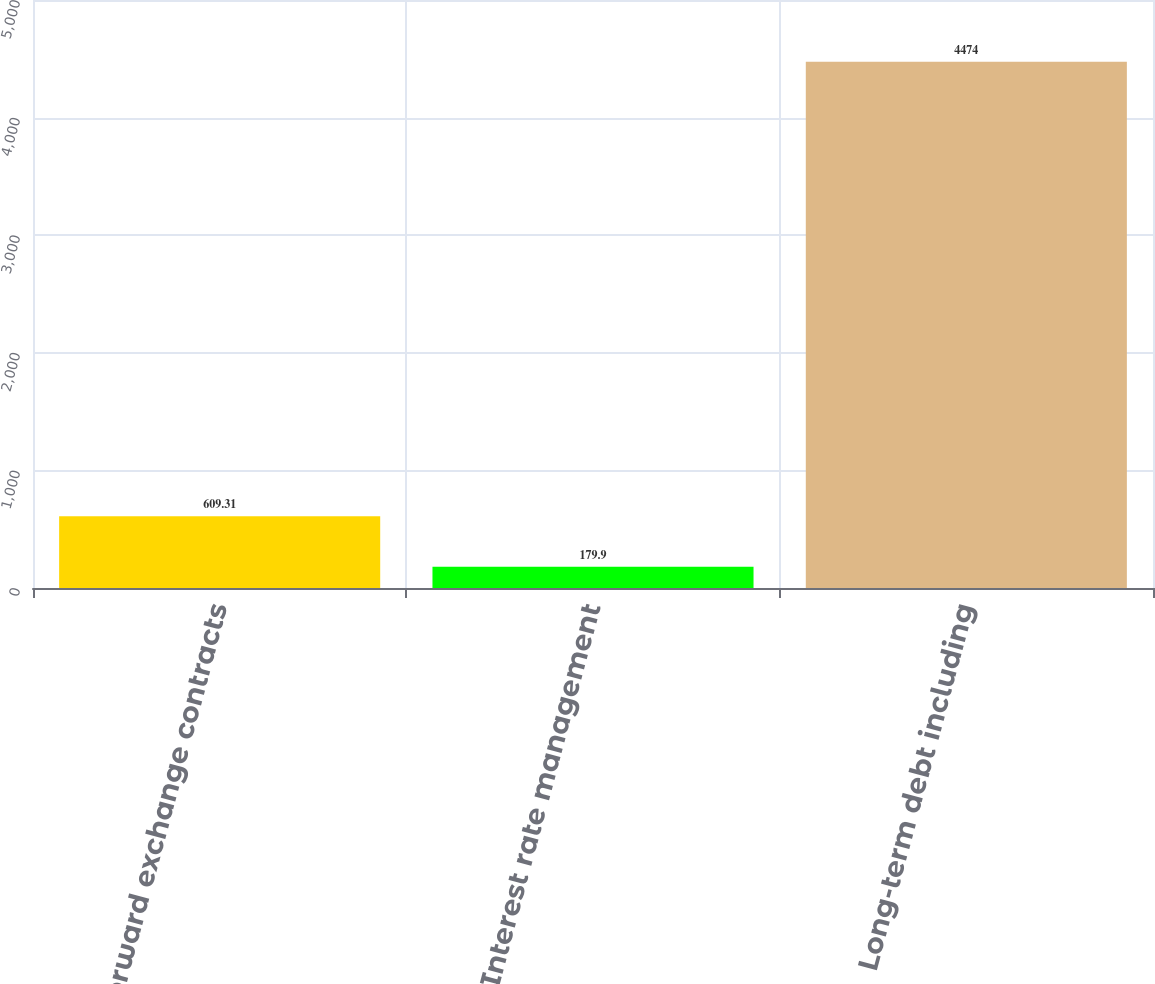Convert chart to OTSL. <chart><loc_0><loc_0><loc_500><loc_500><bar_chart><fcel>Forward exchange contracts<fcel>Interest rate management<fcel>Long-term debt including<nl><fcel>609.31<fcel>179.9<fcel>4474<nl></chart> 